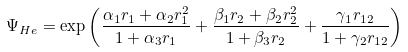Convert formula to latex. <formula><loc_0><loc_0><loc_500><loc_500>\Psi _ { H e } = \exp \left ( \frac { \alpha _ { 1 } r _ { 1 } + \alpha _ { 2 } r _ { 1 } ^ { 2 } } { 1 + \alpha _ { 3 } r _ { 1 } } + \frac { \beta _ { 1 } r _ { 2 } + \beta _ { 2 } r _ { 2 } ^ { 2 } } { 1 + \beta _ { 3 } r _ { 2 } } + \frac { \gamma _ { 1 } r _ { 1 2 } } { 1 + \gamma _ { 2 } r _ { 1 2 } } \right )</formula> 